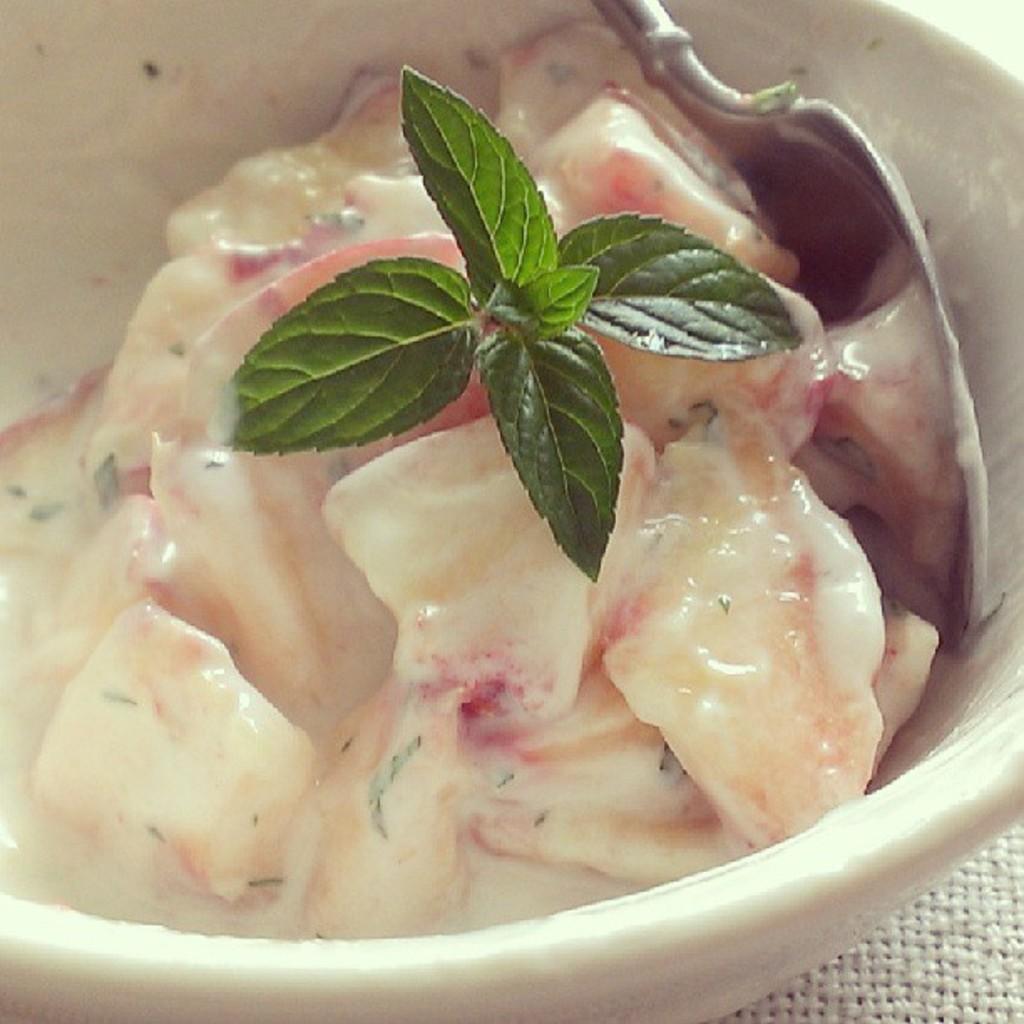How would you summarize this image in a sentence or two? In this picture I can see food items and a spoon in a bowl. 